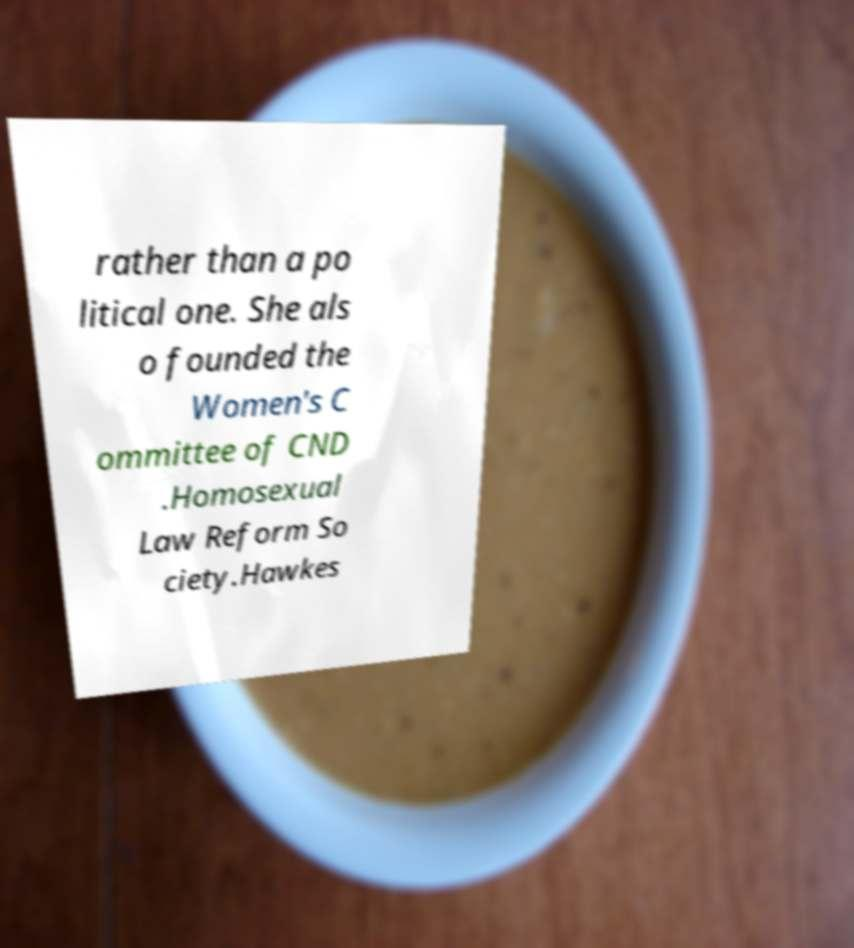Can you read and provide the text displayed in the image?This photo seems to have some interesting text. Can you extract and type it out for me? rather than a po litical one. She als o founded the Women's C ommittee of CND .Homosexual Law Reform So ciety.Hawkes 